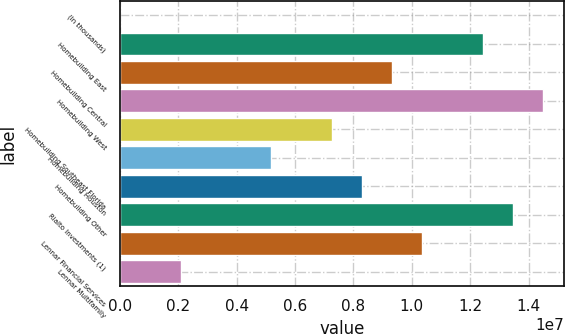Convert chart. <chart><loc_0><loc_0><loc_500><loc_500><bar_chart><fcel>(In thousands)<fcel>Homebuilding East<fcel>Homebuilding Central<fcel>Homebuilding West<fcel>Homebuilding Southeast Florida<fcel>Homebuilding Houston<fcel>Homebuilding Other<fcel>Rialto Investments (1)<fcel>Lennar Financial Services<fcel>Lennar Multifamily<nl><fcel>2012<fcel>1.24342e+07<fcel>9.32619e+06<fcel>1.45063e+07<fcel>7.25415e+06<fcel>5.18211e+06<fcel>8.29017e+06<fcel>1.34703e+07<fcel>1.03622e+07<fcel>2.07405e+06<nl></chart> 